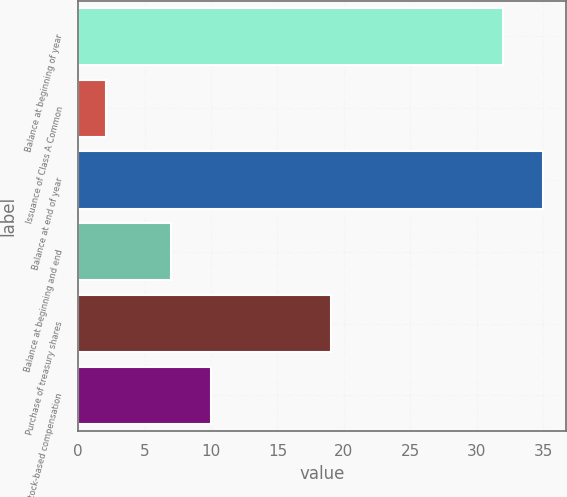<chart> <loc_0><loc_0><loc_500><loc_500><bar_chart><fcel>Balance at beginning of year<fcel>Issuance of Class A Common<fcel>Balance at end of year<fcel>Balance at beginning and end<fcel>Purchase of treasury shares<fcel>Stock-based compensation<nl><fcel>32<fcel>2.09<fcel>34.99<fcel>7<fcel>19<fcel>10<nl></chart> 